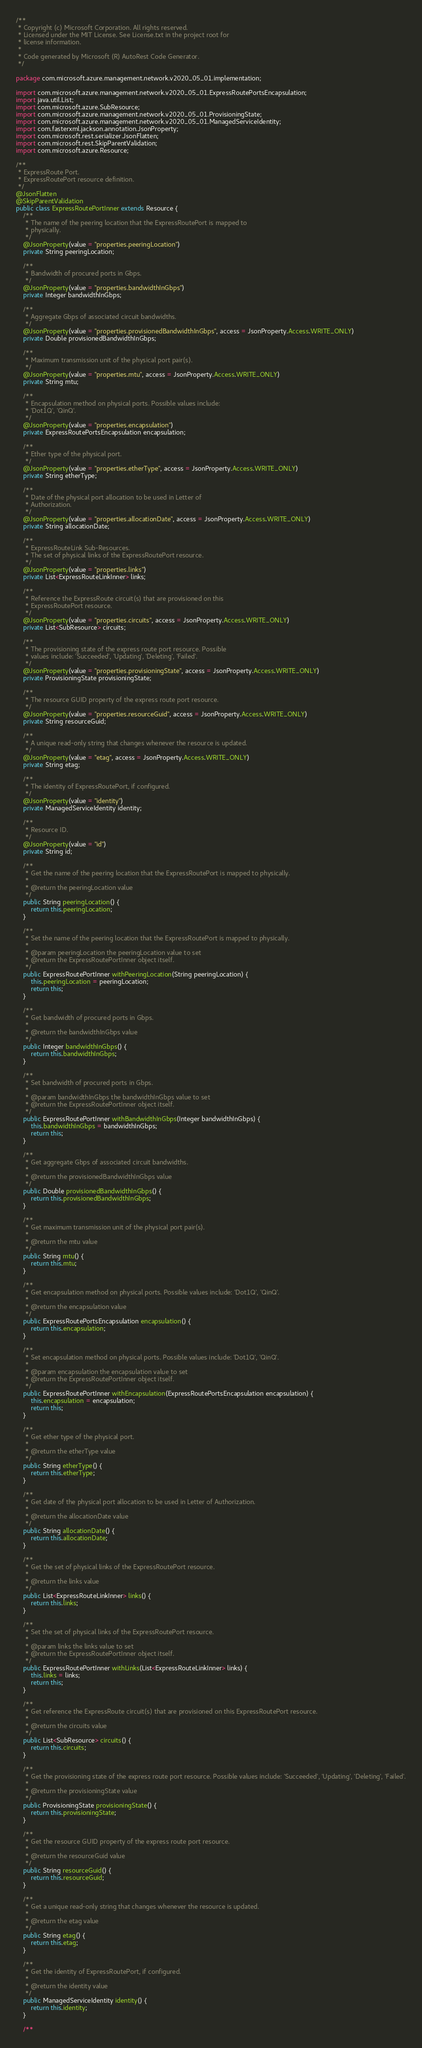<code> <loc_0><loc_0><loc_500><loc_500><_Java_>/**
 * Copyright (c) Microsoft Corporation. All rights reserved.
 * Licensed under the MIT License. See License.txt in the project root for
 * license information.
 *
 * Code generated by Microsoft (R) AutoRest Code Generator.
 */

package com.microsoft.azure.management.network.v2020_05_01.implementation;

import com.microsoft.azure.management.network.v2020_05_01.ExpressRoutePortsEncapsulation;
import java.util.List;
import com.microsoft.azure.SubResource;
import com.microsoft.azure.management.network.v2020_05_01.ProvisioningState;
import com.microsoft.azure.management.network.v2020_05_01.ManagedServiceIdentity;
import com.fasterxml.jackson.annotation.JsonProperty;
import com.microsoft.rest.serializer.JsonFlatten;
import com.microsoft.rest.SkipParentValidation;
import com.microsoft.azure.Resource;

/**
 * ExpressRoute Port.
 * ExpressRoutePort resource definition.
 */
@JsonFlatten
@SkipParentValidation
public class ExpressRoutePortInner extends Resource {
    /**
     * The name of the peering location that the ExpressRoutePort is mapped to
     * physically.
     */
    @JsonProperty(value = "properties.peeringLocation")
    private String peeringLocation;

    /**
     * Bandwidth of procured ports in Gbps.
     */
    @JsonProperty(value = "properties.bandwidthInGbps")
    private Integer bandwidthInGbps;

    /**
     * Aggregate Gbps of associated circuit bandwidths.
     */
    @JsonProperty(value = "properties.provisionedBandwidthInGbps", access = JsonProperty.Access.WRITE_ONLY)
    private Double provisionedBandwidthInGbps;

    /**
     * Maximum transmission unit of the physical port pair(s).
     */
    @JsonProperty(value = "properties.mtu", access = JsonProperty.Access.WRITE_ONLY)
    private String mtu;

    /**
     * Encapsulation method on physical ports. Possible values include:
     * 'Dot1Q', 'QinQ'.
     */
    @JsonProperty(value = "properties.encapsulation")
    private ExpressRoutePortsEncapsulation encapsulation;

    /**
     * Ether type of the physical port.
     */
    @JsonProperty(value = "properties.etherType", access = JsonProperty.Access.WRITE_ONLY)
    private String etherType;

    /**
     * Date of the physical port allocation to be used in Letter of
     * Authorization.
     */
    @JsonProperty(value = "properties.allocationDate", access = JsonProperty.Access.WRITE_ONLY)
    private String allocationDate;

    /**
     * ExpressRouteLink Sub-Resources.
     * The set of physical links of the ExpressRoutePort resource.
     */
    @JsonProperty(value = "properties.links")
    private List<ExpressRouteLinkInner> links;

    /**
     * Reference the ExpressRoute circuit(s) that are provisioned on this
     * ExpressRoutePort resource.
     */
    @JsonProperty(value = "properties.circuits", access = JsonProperty.Access.WRITE_ONLY)
    private List<SubResource> circuits;

    /**
     * The provisioning state of the express route port resource. Possible
     * values include: 'Succeeded', 'Updating', 'Deleting', 'Failed'.
     */
    @JsonProperty(value = "properties.provisioningState", access = JsonProperty.Access.WRITE_ONLY)
    private ProvisioningState provisioningState;

    /**
     * The resource GUID property of the express route port resource.
     */
    @JsonProperty(value = "properties.resourceGuid", access = JsonProperty.Access.WRITE_ONLY)
    private String resourceGuid;

    /**
     * A unique read-only string that changes whenever the resource is updated.
     */
    @JsonProperty(value = "etag", access = JsonProperty.Access.WRITE_ONLY)
    private String etag;

    /**
     * The identity of ExpressRoutePort, if configured.
     */
    @JsonProperty(value = "identity")
    private ManagedServiceIdentity identity;

    /**
     * Resource ID.
     */
    @JsonProperty(value = "id")
    private String id;

    /**
     * Get the name of the peering location that the ExpressRoutePort is mapped to physically.
     *
     * @return the peeringLocation value
     */
    public String peeringLocation() {
        return this.peeringLocation;
    }

    /**
     * Set the name of the peering location that the ExpressRoutePort is mapped to physically.
     *
     * @param peeringLocation the peeringLocation value to set
     * @return the ExpressRoutePortInner object itself.
     */
    public ExpressRoutePortInner withPeeringLocation(String peeringLocation) {
        this.peeringLocation = peeringLocation;
        return this;
    }

    /**
     * Get bandwidth of procured ports in Gbps.
     *
     * @return the bandwidthInGbps value
     */
    public Integer bandwidthInGbps() {
        return this.bandwidthInGbps;
    }

    /**
     * Set bandwidth of procured ports in Gbps.
     *
     * @param bandwidthInGbps the bandwidthInGbps value to set
     * @return the ExpressRoutePortInner object itself.
     */
    public ExpressRoutePortInner withBandwidthInGbps(Integer bandwidthInGbps) {
        this.bandwidthInGbps = bandwidthInGbps;
        return this;
    }

    /**
     * Get aggregate Gbps of associated circuit bandwidths.
     *
     * @return the provisionedBandwidthInGbps value
     */
    public Double provisionedBandwidthInGbps() {
        return this.provisionedBandwidthInGbps;
    }

    /**
     * Get maximum transmission unit of the physical port pair(s).
     *
     * @return the mtu value
     */
    public String mtu() {
        return this.mtu;
    }

    /**
     * Get encapsulation method on physical ports. Possible values include: 'Dot1Q', 'QinQ'.
     *
     * @return the encapsulation value
     */
    public ExpressRoutePortsEncapsulation encapsulation() {
        return this.encapsulation;
    }

    /**
     * Set encapsulation method on physical ports. Possible values include: 'Dot1Q', 'QinQ'.
     *
     * @param encapsulation the encapsulation value to set
     * @return the ExpressRoutePortInner object itself.
     */
    public ExpressRoutePortInner withEncapsulation(ExpressRoutePortsEncapsulation encapsulation) {
        this.encapsulation = encapsulation;
        return this;
    }

    /**
     * Get ether type of the physical port.
     *
     * @return the etherType value
     */
    public String etherType() {
        return this.etherType;
    }

    /**
     * Get date of the physical port allocation to be used in Letter of Authorization.
     *
     * @return the allocationDate value
     */
    public String allocationDate() {
        return this.allocationDate;
    }

    /**
     * Get the set of physical links of the ExpressRoutePort resource.
     *
     * @return the links value
     */
    public List<ExpressRouteLinkInner> links() {
        return this.links;
    }

    /**
     * Set the set of physical links of the ExpressRoutePort resource.
     *
     * @param links the links value to set
     * @return the ExpressRoutePortInner object itself.
     */
    public ExpressRoutePortInner withLinks(List<ExpressRouteLinkInner> links) {
        this.links = links;
        return this;
    }

    /**
     * Get reference the ExpressRoute circuit(s) that are provisioned on this ExpressRoutePort resource.
     *
     * @return the circuits value
     */
    public List<SubResource> circuits() {
        return this.circuits;
    }

    /**
     * Get the provisioning state of the express route port resource. Possible values include: 'Succeeded', 'Updating', 'Deleting', 'Failed'.
     *
     * @return the provisioningState value
     */
    public ProvisioningState provisioningState() {
        return this.provisioningState;
    }

    /**
     * Get the resource GUID property of the express route port resource.
     *
     * @return the resourceGuid value
     */
    public String resourceGuid() {
        return this.resourceGuid;
    }

    /**
     * Get a unique read-only string that changes whenever the resource is updated.
     *
     * @return the etag value
     */
    public String etag() {
        return this.etag;
    }

    /**
     * Get the identity of ExpressRoutePort, if configured.
     *
     * @return the identity value
     */
    public ManagedServiceIdentity identity() {
        return this.identity;
    }

    /**</code> 